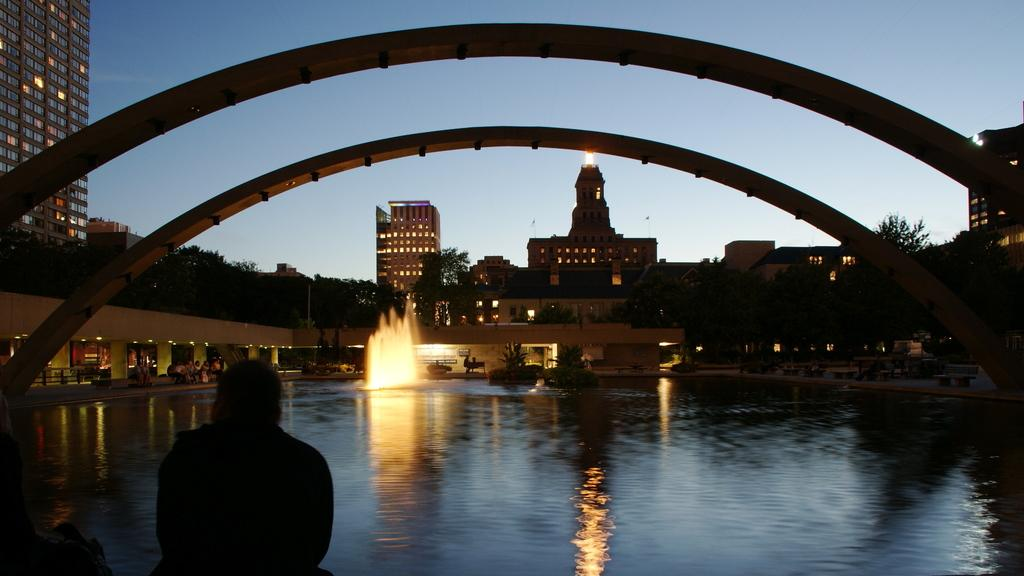What type of structures can be seen in the image? There are buildings in the image. What else is visible in the image besides the buildings? There are lights, a fountain, water, people, an arch, trees, and the sky visible in the image. Can you describe the fountain in the image? The fountain is a water feature that can be seen in the image. How many people are near the building in the image? There are people near the building in the image, but the exact number cannot be determined from the image. What is visible in the background of the image? The sky is visible in the background of the image. What type of cord is being used to transport the truck in the image? There is no cord or truck present in the image. How does the truck move around in the image? There is no truck present in the image, so it cannot be determined how it moves around. 